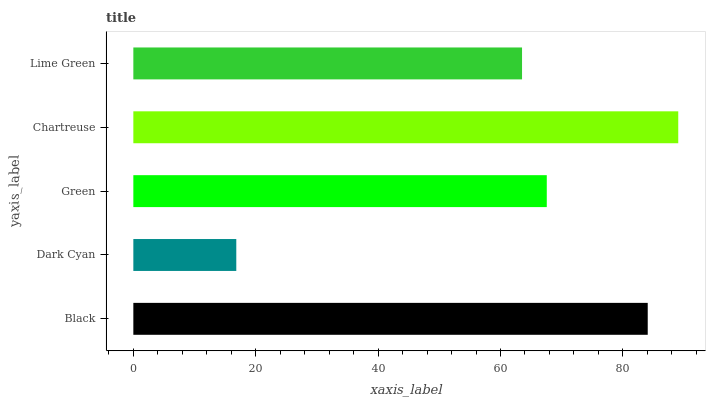Is Dark Cyan the minimum?
Answer yes or no. Yes. Is Chartreuse the maximum?
Answer yes or no. Yes. Is Green the minimum?
Answer yes or no. No. Is Green the maximum?
Answer yes or no. No. Is Green greater than Dark Cyan?
Answer yes or no. Yes. Is Dark Cyan less than Green?
Answer yes or no. Yes. Is Dark Cyan greater than Green?
Answer yes or no. No. Is Green less than Dark Cyan?
Answer yes or no. No. Is Green the high median?
Answer yes or no. Yes. Is Green the low median?
Answer yes or no. Yes. Is Dark Cyan the high median?
Answer yes or no. No. Is Black the low median?
Answer yes or no. No. 